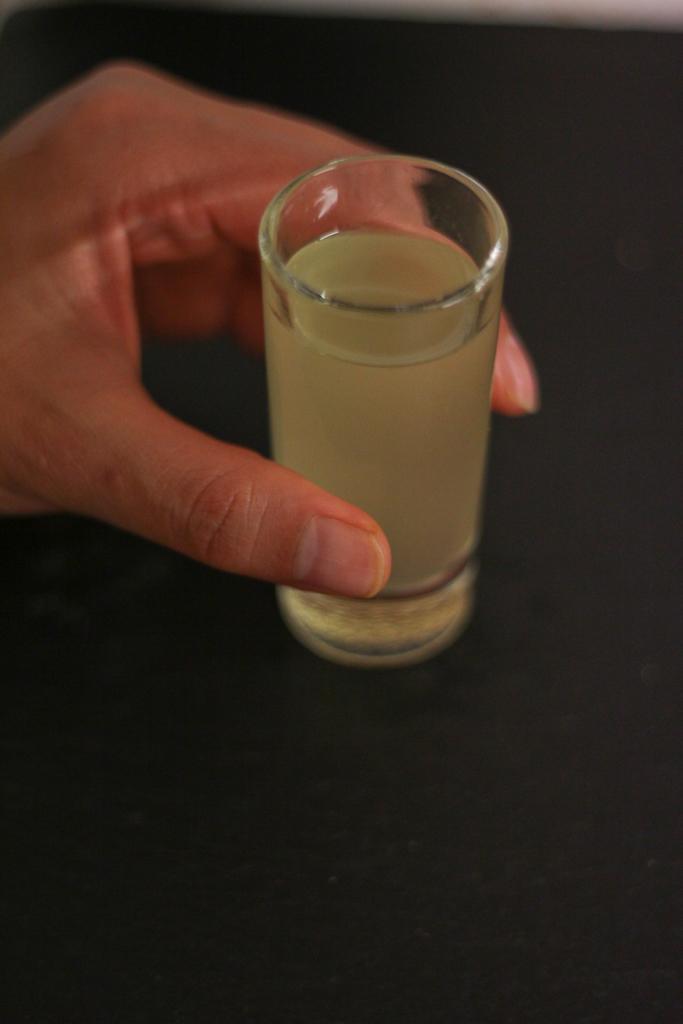How would you summarize this image in a sentence or two? We can see a person hand holding a glass with drink on the black surface. 